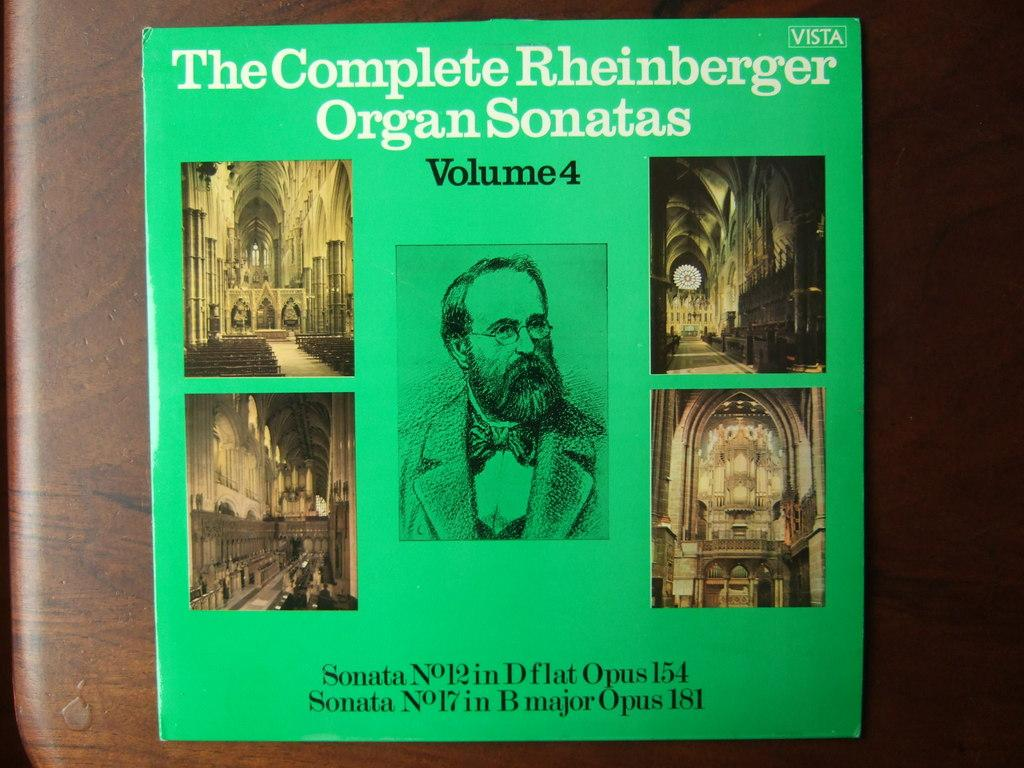What is placed on the table in the image? There is a book placed on a table. What type of finger can be seen holding the book in the image? There is no finger holding the book in the image; it is placed on the table. What type of volleyball game is being played in the background of the image? There is no volleyball game present in the image; it only features a book placed on a table. What type of plate is visible on the table next to the book in the image? There is no plate visible on the table next to the book in the image. 